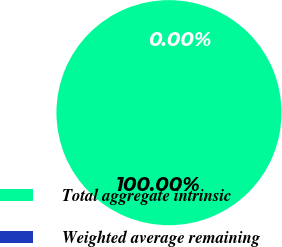<chart> <loc_0><loc_0><loc_500><loc_500><pie_chart><fcel>Total aggregate intrinsic<fcel>Weighted average remaining<nl><fcel>100.0%<fcel>0.0%<nl></chart> 